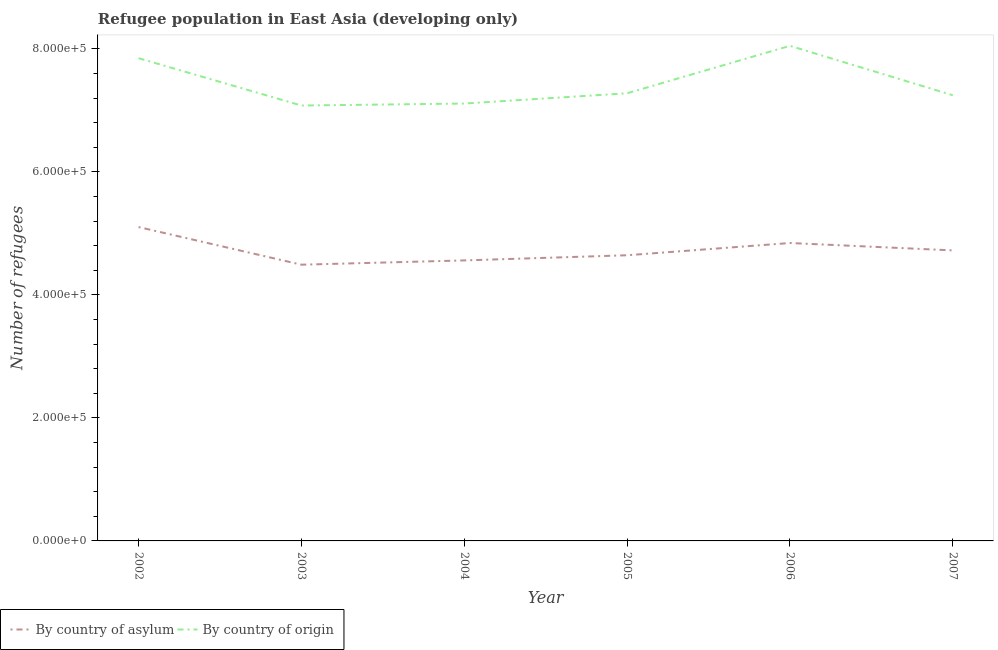Is the number of lines equal to the number of legend labels?
Offer a very short reply. Yes. What is the number of refugees by country of origin in 2002?
Provide a short and direct response. 7.85e+05. Across all years, what is the maximum number of refugees by country of origin?
Provide a short and direct response. 8.05e+05. Across all years, what is the minimum number of refugees by country of origin?
Provide a short and direct response. 7.08e+05. In which year was the number of refugees by country of origin maximum?
Keep it short and to the point. 2006. What is the total number of refugees by country of origin in the graph?
Provide a short and direct response. 4.46e+06. What is the difference between the number of refugees by country of asylum in 2003 and that in 2007?
Keep it short and to the point. -2.32e+04. What is the difference between the number of refugees by country of origin in 2005 and the number of refugees by country of asylum in 2007?
Offer a very short reply. 2.55e+05. What is the average number of refugees by country of asylum per year?
Offer a terse response. 4.73e+05. In the year 2003, what is the difference between the number of refugees by country of asylum and number of refugees by country of origin?
Offer a terse response. -2.59e+05. What is the ratio of the number of refugees by country of origin in 2002 to that in 2005?
Keep it short and to the point. 1.08. What is the difference between the highest and the second highest number of refugees by country of origin?
Ensure brevity in your answer.  2.01e+04. What is the difference between the highest and the lowest number of refugees by country of origin?
Give a very brief answer. 9.71e+04. In how many years, is the number of refugees by country of asylum greater than the average number of refugees by country of asylum taken over all years?
Provide a short and direct response. 2. Is the sum of the number of refugees by country of origin in 2004 and 2007 greater than the maximum number of refugees by country of asylum across all years?
Provide a short and direct response. Yes. Does the number of refugees by country of asylum monotonically increase over the years?
Your answer should be compact. No. How many lines are there?
Provide a short and direct response. 2. Are the values on the major ticks of Y-axis written in scientific E-notation?
Offer a terse response. Yes. How many legend labels are there?
Provide a short and direct response. 2. What is the title of the graph?
Your answer should be very brief. Refugee population in East Asia (developing only). Does "Register a property" appear as one of the legend labels in the graph?
Provide a short and direct response. No. What is the label or title of the Y-axis?
Your response must be concise. Number of refugees. What is the Number of refugees in By country of asylum in 2002?
Your answer should be very brief. 5.10e+05. What is the Number of refugees of By country of origin in 2002?
Keep it short and to the point. 7.85e+05. What is the Number of refugees in By country of asylum in 2003?
Ensure brevity in your answer.  4.49e+05. What is the Number of refugees in By country of origin in 2003?
Ensure brevity in your answer.  7.08e+05. What is the Number of refugees in By country of asylum in 2004?
Offer a very short reply. 4.56e+05. What is the Number of refugees of By country of origin in 2004?
Your response must be concise. 7.11e+05. What is the Number of refugees of By country of asylum in 2005?
Provide a short and direct response. 4.64e+05. What is the Number of refugees of By country of origin in 2005?
Offer a terse response. 7.28e+05. What is the Number of refugees of By country of asylum in 2006?
Offer a terse response. 4.84e+05. What is the Number of refugees in By country of origin in 2006?
Make the answer very short. 8.05e+05. What is the Number of refugees of By country of asylum in 2007?
Ensure brevity in your answer.  4.72e+05. What is the Number of refugees of By country of origin in 2007?
Your answer should be compact. 7.25e+05. Across all years, what is the maximum Number of refugees of By country of asylum?
Provide a short and direct response. 5.10e+05. Across all years, what is the maximum Number of refugees of By country of origin?
Make the answer very short. 8.05e+05. Across all years, what is the minimum Number of refugees of By country of asylum?
Your answer should be compact. 4.49e+05. Across all years, what is the minimum Number of refugees of By country of origin?
Keep it short and to the point. 7.08e+05. What is the total Number of refugees in By country of asylum in the graph?
Give a very brief answer. 2.84e+06. What is the total Number of refugees of By country of origin in the graph?
Your answer should be compact. 4.46e+06. What is the difference between the Number of refugees in By country of asylum in 2002 and that in 2003?
Your answer should be very brief. 6.12e+04. What is the difference between the Number of refugees in By country of origin in 2002 and that in 2003?
Keep it short and to the point. 7.69e+04. What is the difference between the Number of refugees of By country of asylum in 2002 and that in 2004?
Keep it short and to the point. 5.42e+04. What is the difference between the Number of refugees in By country of origin in 2002 and that in 2004?
Provide a succinct answer. 7.37e+04. What is the difference between the Number of refugees in By country of asylum in 2002 and that in 2005?
Your answer should be compact. 4.58e+04. What is the difference between the Number of refugees of By country of origin in 2002 and that in 2005?
Offer a terse response. 5.70e+04. What is the difference between the Number of refugees of By country of asylum in 2002 and that in 2006?
Your answer should be compact. 2.59e+04. What is the difference between the Number of refugees in By country of origin in 2002 and that in 2006?
Your answer should be compact. -2.01e+04. What is the difference between the Number of refugees of By country of asylum in 2002 and that in 2007?
Give a very brief answer. 3.80e+04. What is the difference between the Number of refugees of By country of origin in 2002 and that in 2007?
Give a very brief answer. 6.02e+04. What is the difference between the Number of refugees in By country of asylum in 2003 and that in 2004?
Give a very brief answer. -6965. What is the difference between the Number of refugees of By country of origin in 2003 and that in 2004?
Make the answer very short. -3245. What is the difference between the Number of refugees in By country of asylum in 2003 and that in 2005?
Keep it short and to the point. -1.54e+04. What is the difference between the Number of refugees in By country of origin in 2003 and that in 2005?
Your response must be concise. -1.99e+04. What is the difference between the Number of refugees in By country of asylum in 2003 and that in 2006?
Your response must be concise. -3.53e+04. What is the difference between the Number of refugees of By country of origin in 2003 and that in 2006?
Your answer should be compact. -9.71e+04. What is the difference between the Number of refugees in By country of asylum in 2003 and that in 2007?
Your response must be concise. -2.32e+04. What is the difference between the Number of refugees in By country of origin in 2003 and that in 2007?
Provide a short and direct response. -1.67e+04. What is the difference between the Number of refugees in By country of asylum in 2004 and that in 2005?
Make the answer very short. -8391. What is the difference between the Number of refugees in By country of origin in 2004 and that in 2005?
Ensure brevity in your answer.  -1.67e+04. What is the difference between the Number of refugees in By country of asylum in 2004 and that in 2006?
Provide a succinct answer. -2.83e+04. What is the difference between the Number of refugees of By country of origin in 2004 and that in 2006?
Offer a very short reply. -9.38e+04. What is the difference between the Number of refugees in By country of asylum in 2004 and that in 2007?
Your answer should be very brief. -1.63e+04. What is the difference between the Number of refugees in By country of origin in 2004 and that in 2007?
Ensure brevity in your answer.  -1.35e+04. What is the difference between the Number of refugees of By country of asylum in 2005 and that in 2006?
Ensure brevity in your answer.  -1.99e+04. What is the difference between the Number of refugees in By country of origin in 2005 and that in 2006?
Offer a terse response. -7.72e+04. What is the difference between the Number of refugees of By country of asylum in 2005 and that in 2007?
Your answer should be compact. -7890. What is the difference between the Number of refugees in By country of origin in 2005 and that in 2007?
Give a very brief answer. 3184. What is the difference between the Number of refugees in By country of asylum in 2006 and that in 2007?
Your answer should be very brief. 1.20e+04. What is the difference between the Number of refugees in By country of origin in 2006 and that in 2007?
Provide a succinct answer. 8.03e+04. What is the difference between the Number of refugees in By country of asylum in 2002 and the Number of refugees in By country of origin in 2003?
Provide a succinct answer. -1.98e+05. What is the difference between the Number of refugees of By country of asylum in 2002 and the Number of refugees of By country of origin in 2004?
Offer a terse response. -2.01e+05. What is the difference between the Number of refugees of By country of asylum in 2002 and the Number of refugees of By country of origin in 2005?
Your answer should be compact. -2.18e+05. What is the difference between the Number of refugees in By country of asylum in 2002 and the Number of refugees in By country of origin in 2006?
Give a very brief answer. -2.95e+05. What is the difference between the Number of refugees in By country of asylum in 2002 and the Number of refugees in By country of origin in 2007?
Offer a terse response. -2.14e+05. What is the difference between the Number of refugees of By country of asylum in 2003 and the Number of refugees of By country of origin in 2004?
Provide a short and direct response. -2.62e+05. What is the difference between the Number of refugees in By country of asylum in 2003 and the Number of refugees in By country of origin in 2005?
Your answer should be compact. -2.79e+05. What is the difference between the Number of refugees of By country of asylum in 2003 and the Number of refugees of By country of origin in 2006?
Offer a very short reply. -3.56e+05. What is the difference between the Number of refugees of By country of asylum in 2003 and the Number of refugees of By country of origin in 2007?
Make the answer very short. -2.76e+05. What is the difference between the Number of refugees in By country of asylum in 2004 and the Number of refugees in By country of origin in 2005?
Your answer should be very brief. -2.72e+05. What is the difference between the Number of refugees in By country of asylum in 2004 and the Number of refugees in By country of origin in 2006?
Your response must be concise. -3.49e+05. What is the difference between the Number of refugees in By country of asylum in 2004 and the Number of refugees in By country of origin in 2007?
Offer a terse response. -2.69e+05. What is the difference between the Number of refugees in By country of asylum in 2005 and the Number of refugees in By country of origin in 2006?
Ensure brevity in your answer.  -3.41e+05. What is the difference between the Number of refugees in By country of asylum in 2005 and the Number of refugees in By country of origin in 2007?
Provide a short and direct response. -2.60e+05. What is the difference between the Number of refugees in By country of asylum in 2006 and the Number of refugees in By country of origin in 2007?
Give a very brief answer. -2.40e+05. What is the average Number of refugees of By country of asylum per year?
Provide a succinct answer. 4.73e+05. What is the average Number of refugees of By country of origin per year?
Your response must be concise. 7.44e+05. In the year 2002, what is the difference between the Number of refugees of By country of asylum and Number of refugees of By country of origin?
Your answer should be very brief. -2.75e+05. In the year 2003, what is the difference between the Number of refugees in By country of asylum and Number of refugees in By country of origin?
Your response must be concise. -2.59e+05. In the year 2004, what is the difference between the Number of refugees of By country of asylum and Number of refugees of By country of origin?
Keep it short and to the point. -2.55e+05. In the year 2005, what is the difference between the Number of refugees in By country of asylum and Number of refugees in By country of origin?
Your answer should be very brief. -2.63e+05. In the year 2006, what is the difference between the Number of refugees in By country of asylum and Number of refugees in By country of origin?
Make the answer very short. -3.21e+05. In the year 2007, what is the difference between the Number of refugees of By country of asylum and Number of refugees of By country of origin?
Give a very brief answer. -2.52e+05. What is the ratio of the Number of refugees in By country of asylum in 2002 to that in 2003?
Your answer should be compact. 1.14. What is the ratio of the Number of refugees in By country of origin in 2002 to that in 2003?
Your answer should be very brief. 1.11. What is the ratio of the Number of refugees of By country of asylum in 2002 to that in 2004?
Your answer should be very brief. 1.12. What is the ratio of the Number of refugees in By country of origin in 2002 to that in 2004?
Give a very brief answer. 1.1. What is the ratio of the Number of refugees in By country of asylum in 2002 to that in 2005?
Ensure brevity in your answer.  1.1. What is the ratio of the Number of refugees in By country of origin in 2002 to that in 2005?
Your answer should be compact. 1.08. What is the ratio of the Number of refugees in By country of asylum in 2002 to that in 2006?
Provide a succinct answer. 1.05. What is the ratio of the Number of refugees of By country of origin in 2002 to that in 2006?
Your response must be concise. 0.97. What is the ratio of the Number of refugees of By country of asylum in 2002 to that in 2007?
Your answer should be very brief. 1.08. What is the ratio of the Number of refugees in By country of origin in 2002 to that in 2007?
Keep it short and to the point. 1.08. What is the ratio of the Number of refugees of By country of asylum in 2003 to that in 2004?
Offer a very short reply. 0.98. What is the ratio of the Number of refugees in By country of asylum in 2003 to that in 2005?
Keep it short and to the point. 0.97. What is the ratio of the Number of refugees of By country of origin in 2003 to that in 2005?
Offer a terse response. 0.97. What is the ratio of the Number of refugees in By country of asylum in 2003 to that in 2006?
Keep it short and to the point. 0.93. What is the ratio of the Number of refugees of By country of origin in 2003 to that in 2006?
Offer a terse response. 0.88. What is the ratio of the Number of refugees of By country of asylum in 2003 to that in 2007?
Provide a succinct answer. 0.95. What is the ratio of the Number of refugees of By country of origin in 2003 to that in 2007?
Offer a terse response. 0.98. What is the ratio of the Number of refugees of By country of asylum in 2004 to that in 2005?
Ensure brevity in your answer.  0.98. What is the ratio of the Number of refugees in By country of origin in 2004 to that in 2005?
Your answer should be compact. 0.98. What is the ratio of the Number of refugees of By country of asylum in 2004 to that in 2006?
Ensure brevity in your answer.  0.94. What is the ratio of the Number of refugees in By country of origin in 2004 to that in 2006?
Your answer should be very brief. 0.88. What is the ratio of the Number of refugees of By country of asylum in 2004 to that in 2007?
Make the answer very short. 0.97. What is the ratio of the Number of refugees in By country of origin in 2004 to that in 2007?
Your response must be concise. 0.98. What is the ratio of the Number of refugees of By country of asylum in 2005 to that in 2006?
Make the answer very short. 0.96. What is the ratio of the Number of refugees in By country of origin in 2005 to that in 2006?
Offer a terse response. 0.9. What is the ratio of the Number of refugees in By country of asylum in 2005 to that in 2007?
Ensure brevity in your answer.  0.98. What is the ratio of the Number of refugees in By country of origin in 2005 to that in 2007?
Keep it short and to the point. 1. What is the ratio of the Number of refugees of By country of asylum in 2006 to that in 2007?
Make the answer very short. 1.03. What is the ratio of the Number of refugees in By country of origin in 2006 to that in 2007?
Give a very brief answer. 1.11. What is the difference between the highest and the second highest Number of refugees of By country of asylum?
Your answer should be compact. 2.59e+04. What is the difference between the highest and the second highest Number of refugees in By country of origin?
Your answer should be compact. 2.01e+04. What is the difference between the highest and the lowest Number of refugees in By country of asylum?
Your answer should be compact. 6.12e+04. What is the difference between the highest and the lowest Number of refugees of By country of origin?
Keep it short and to the point. 9.71e+04. 